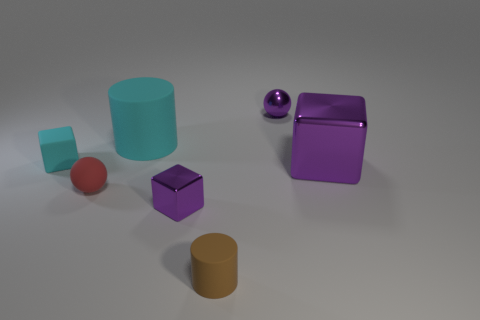Add 2 cyan matte cubes. How many objects exist? 9 Subtract all cubes. How many objects are left? 4 Add 4 large cyan cylinders. How many large cyan cylinders exist? 5 Subtract 0 red cylinders. How many objects are left? 7 Subtract all tiny shiny blocks. Subtract all tiny metallic spheres. How many objects are left? 5 Add 4 shiny spheres. How many shiny spheres are left? 5 